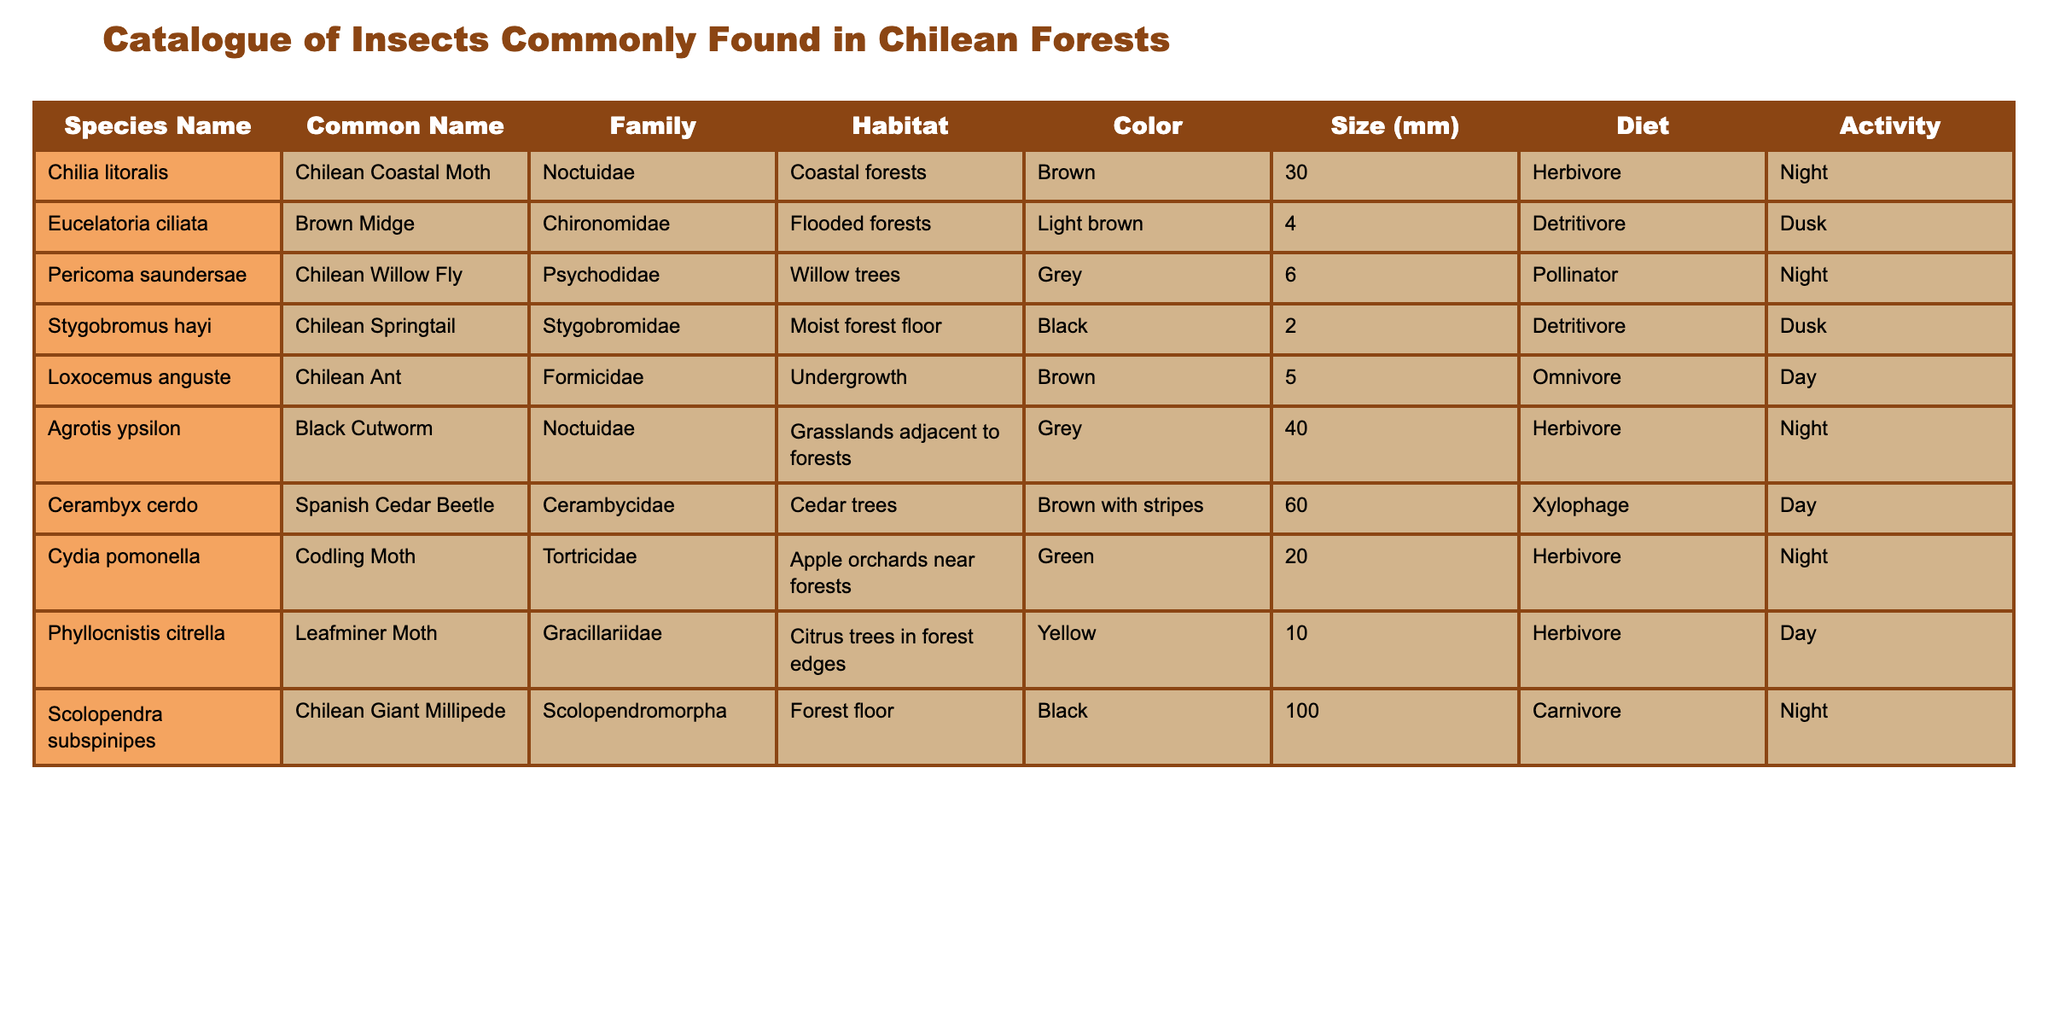What is the common name of the species "Chilia litoralis"? The common name is listed directly in the table under the "Common Name" column for the corresponding species name "Chilia litoralis".
Answer: Chilean Coastal Moth Which insect has the largest size in millimeters? By reviewing the "Size (mm)" column, we see that "Scolopendra subspinipes" measures 100 mm, which is larger than all other sizes listed.
Answer: 100 mm How many insects are herbivores in the table? In the "Diet" column, we count the entries that mention "Herbivore". Checking through the table, we find three herbivores: "Chilean Coastal Moth", "Black Cutworm", "Codling Moth", and "Leafminer Moth". This sums up to 4.
Answer: 4 Is the "Chilean Springtail" a carnivore? The "Diet" column indicates that "Chilean Springtail" has a diet of "Detritivore". Since this is not "Carnivore", the statement is false.
Answer: No What is the average size of all insects listed in the table? We need to sum all the sizes from the "Size (mm)" column: 30 + 4 + 6 + 2 + 5 + 40 + 60 + 20 + 10 + 100 = 277 mm. Since there are 10 species, we calculate the average as 277 / 10 = 27.7 mm.
Answer: 27.7 mm Which two species are active during the night? By reviewing the "Activity" column, we find "Chilean Coastal Moth", "Chilean Willow Fly", "Chilean Giant Millipede" are active at night, while the others are active during the day or at dusk. The query asks for two species, hence we can mention any two of them.
Answer: Chilean Coastal Moth and Chilean Giant Millipede Are there any insects in the "Formicidae" family that are herbivores? The only insect listed under "Formicidae" in the table is "Chilean Ant", and looking at its "Diet" column, it shows "Omnivore". Thus, there are no herbivores in this family.
Answer: No Which species has the same color as "Eucelatoria ciliata"? "Eucelatoria ciliata" is listed with a color of "Light brown". Referring to the "Color" column, we find that no other species matches this color with  "Brown" or "Grey". So, there is no matching species in this case.
Answer: None 